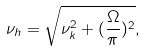<formula> <loc_0><loc_0><loc_500><loc_500>\nu _ { h } = \sqrt { \nu _ { k } ^ { 2 } + ( \frac { \Omega } { \pi } ) ^ { 2 } } ,</formula> 